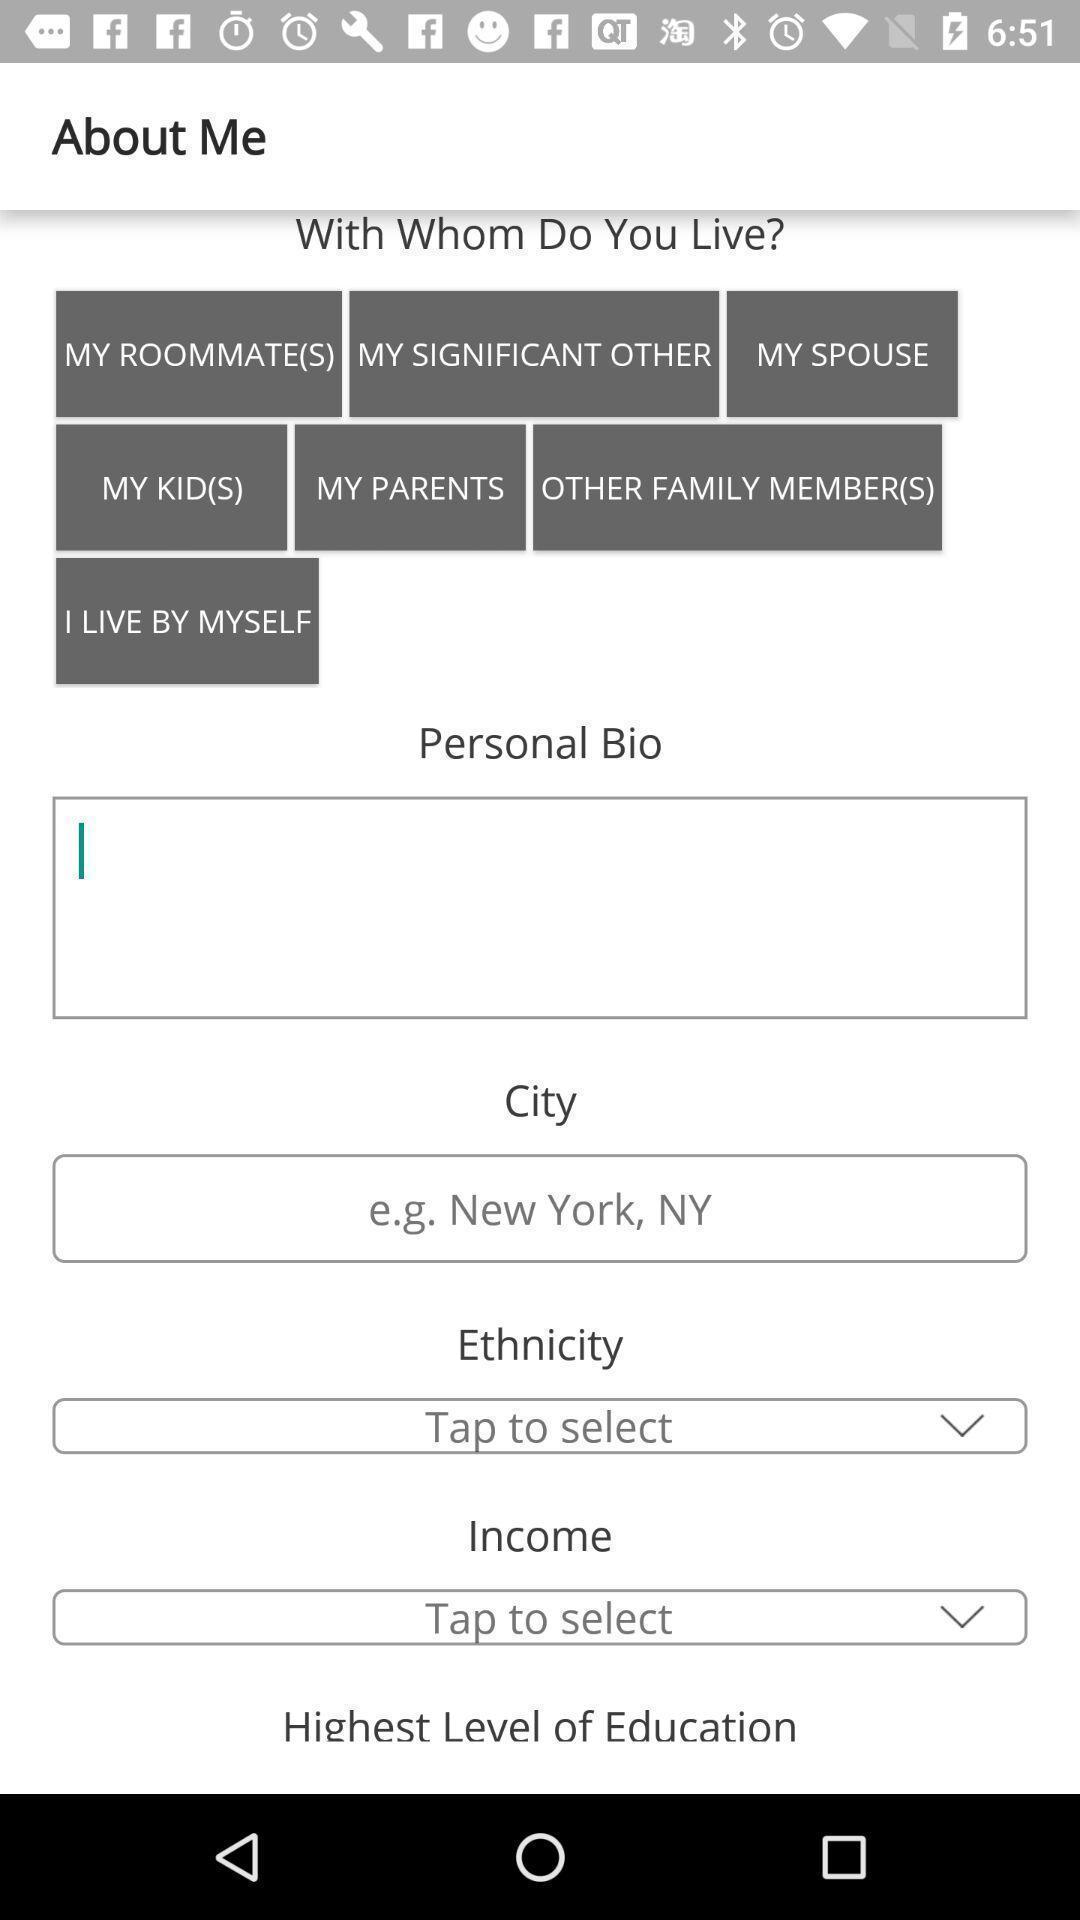What can you discern from this picture? Page displaying to enter the details in shopping application. 